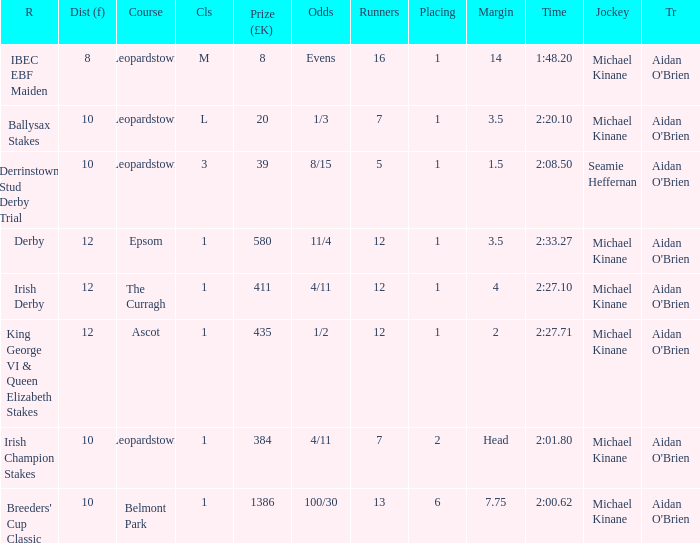Which Race has a Runners of 7 and Odds of 1/3? Ballysax Stakes. 